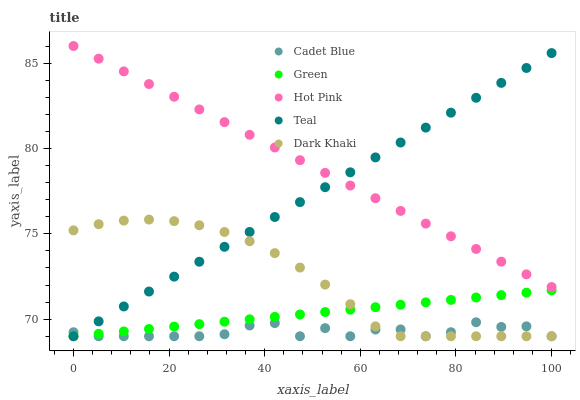Does Cadet Blue have the minimum area under the curve?
Answer yes or no. Yes. Does Hot Pink have the maximum area under the curve?
Answer yes or no. Yes. Does Green have the minimum area under the curve?
Answer yes or no. No. Does Green have the maximum area under the curve?
Answer yes or no. No. Is Green the smoothest?
Answer yes or no. Yes. Is Cadet Blue the roughest?
Answer yes or no. Yes. Is Cadet Blue the smoothest?
Answer yes or no. No. Is Green the roughest?
Answer yes or no. No. Does Dark Khaki have the lowest value?
Answer yes or no. Yes. Does Hot Pink have the lowest value?
Answer yes or no. No. Does Hot Pink have the highest value?
Answer yes or no. Yes. Does Green have the highest value?
Answer yes or no. No. Is Green less than Hot Pink?
Answer yes or no. Yes. Is Hot Pink greater than Cadet Blue?
Answer yes or no. Yes. Does Green intersect Teal?
Answer yes or no. Yes. Is Green less than Teal?
Answer yes or no. No. Is Green greater than Teal?
Answer yes or no. No. Does Green intersect Hot Pink?
Answer yes or no. No. 